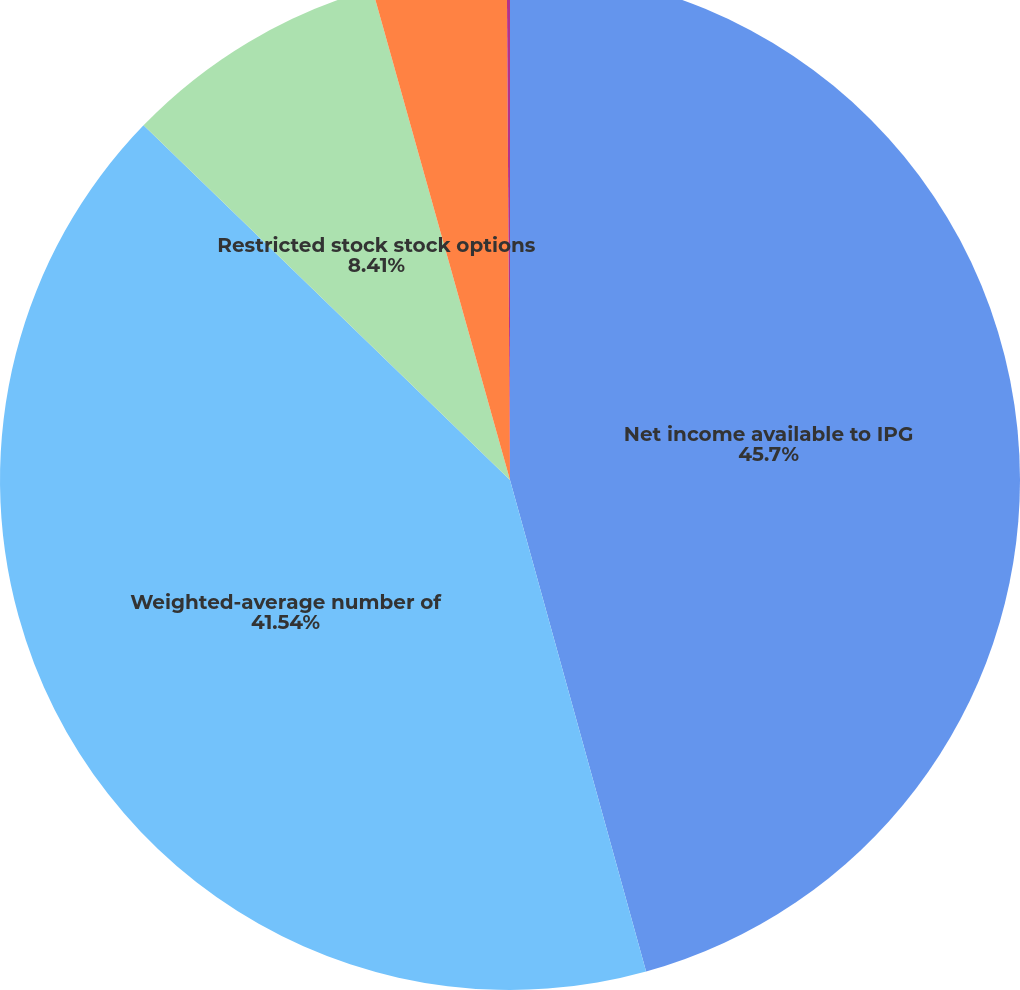Convert chart. <chart><loc_0><loc_0><loc_500><loc_500><pie_chart><fcel>Net income available to IPG<fcel>Weighted-average number of<fcel>Restricted stock stock options<fcel>Basic<fcel>Diluted<nl><fcel>45.7%<fcel>41.54%<fcel>8.41%<fcel>4.25%<fcel>0.1%<nl></chart> 